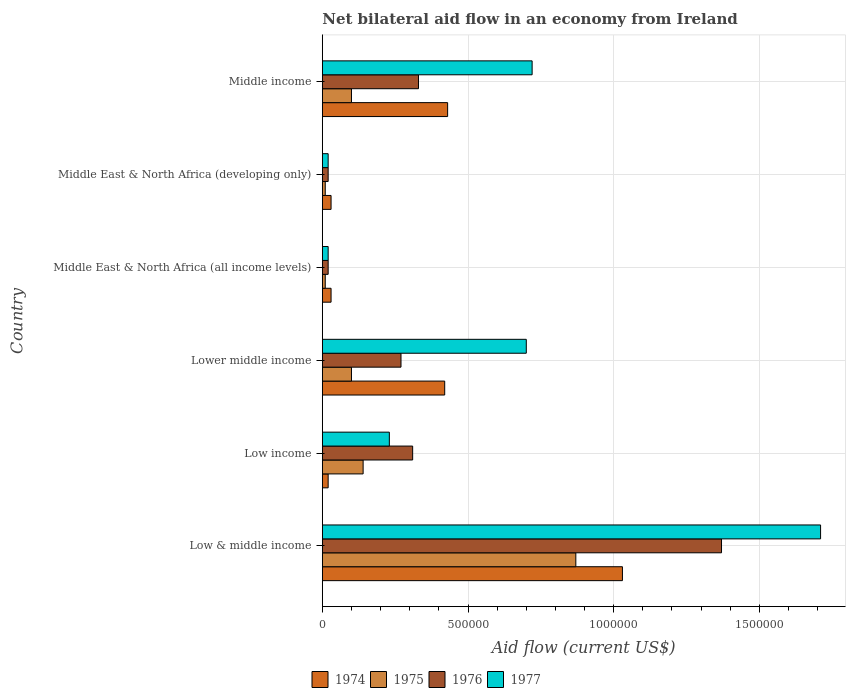How many different coloured bars are there?
Provide a short and direct response. 4. How many groups of bars are there?
Keep it short and to the point. 6. Are the number of bars on each tick of the Y-axis equal?
Provide a short and direct response. Yes. How many bars are there on the 5th tick from the bottom?
Ensure brevity in your answer.  4. What is the label of the 2nd group of bars from the top?
Offer a very short reply. Middle East & North Africa (developing only). In how many cases, is the number of bars for a given country not equal to the number of legend labels?
Provide a short and direct response. 0. Across all countries, what is the maximum net bilateral aid flow in 1974?
Give a very brief answer. 1.03e+06. Across all countries, what is the minimum net bilateral aid flow in 1976?
Give a very brief answer. 2.00e+04. In which country was the net bilateral aid flow in 1975 maximum?
Offer a very short reply. Low & middle income. What is the total net bilateral aid flow in 1977 in the graph?
Your answer should be very brief. 3.40e+06. What is the difference between the net bilateral aid flow in 1974 in Low & middle income and that in Middle income?
Give a very brief answer. 6.00e+05. What is the difference between the net bilateral aid flow in 1977 in Middle East & North Africa (all income levels) and the net bilateral aid flow in 1975 in Low & middle income?
Provide a short and direct response. -8.50e+05. What is the average net bilateral aid flow in 1975 per country?
Give a very brief answer. 2.05e+05. What is the difference between the net bilateral aid flow in 1975 and net bilateral aid flow in 1977 in Middle East & North Africa (developing only)?
Offer a very short reply. -10000. What is the ratio of the net bilateral aid flow in 1977 in Low income to that in Middle East & North Africa (developing only)?
Provide a short and direct response. 11.5. What is the difference between the highest and the second highest net bilateral aid flow in 1976?
Give a very brief answer. 1.04e+06. What is the difference between the highest and the lowest net bilateral aid flow in 1974?
Provide a succinct answer. 1.01e+06. What does the 3rd bar from the top in Lower middle income represents?
Offer a very short reply. 1975. Is it the case that in every country, the sum of the net bilateral aid flow in 1977 and net bilateral aid flow in 1974 is greater than the net bilateral aid flow in 1975?
Provide a short and direct response. Yes. How many bars are there?
Give a very brief answer. 24. How many countries are there in the graph?
Give a very brief answer. 6. Are the values on the major ticks of X-axis written in scientific E-notation?
Give a very brief answer. No. Does the graph contain any zero values?
Your response must be concise. No. Does the graph contain grids?
Your answer should be very brief. Yes. How many legend labels are there?
Give a very brief answer. 4. How are the legend labels stacked?
Your answer should be compact. Horizontal. What is the title of the graph?
Provide a succinct answer. Net bilateral aid flow in an economy from Ireland. What is the Aid flow (current US$) in 1974 in Low & middle income?
Your response must be concise. 1.03e+06. What is the Aid flow (current US$) of 1975 in Low & middle income?
Make the answer very short. 8.70e+05. What is the Aid flow (current US$) of 1976 in Low & middle income?
Offer a terse response. 1.37e+06. What is the Aid flow (current US$) of 1977 in Low & middle income?
Keep it short and to the point. 1.71e+06. What is the Aid flow (current US$) of 1975 in Low income?
Your answer should be compact. 1.40e+05. What is the Aid flow (current US$) of 1976 in Low income?
Offer a terse response. 3.10e+05. What is the Aid flow (current US$) in 1975 in Lower middle income?
Your answer should be very brief. 1.00e+05. What is the Aid flow (current US$) of 1976 in Lower middle income?
Offer a very short reply. 2.70e+05. What is the Aid flow (current US$) in 1977 in Lower middle income?
Make the answer very short. 7.00e+05. What is the Aid flow (current US$) of 1975 in Middle East & North Africa (all income levels)?
Make the answer very short. 10000. What is the Aid flow (current US$) of 1977 in Middle East & North Africa (all income levels)?
Keep it short and to the point. 2.00e+04. What is the Aid flow (current US$) of 1975 in Middle East & North Africa (developing only)?
Provide a short and direct response. 10000. What is the Aid flow (current US$) in 1976 in Middle East & North Africa (developing only)?
Make the answer very short. 2.00e+04. What is the Aid flow (current US$) of 1977 in Middle East & North Africa (developing only)?
Offer a very short reply. 2.00e+04. What is the Aid flow (current US$) in 1975 in Middle income?
Provide a succinct answer. 1.00e+05. What is the Aid flow (current US$) in 1977 in Middle income?
Offer a terse response. 7.20e+05. Across all countries, what is the maximum Aid flow (current US$) of 1974?
Your response must be concise. 1.03e+06. Across all countries, what is the maximum Aid flow (current US$) in 1975?
Provide a succinct answer. 8.70e+05. Across all countries, what is the maximum Aid flow (current US$) in 1976?
Your answer should be compact. 1.37e+06. Across all countries, what is the maximum Aid flow (current US$) in 1977?
Give a very brief answer. 1.71e+06. Across all countries, what is the minimum Aid flow (current US$) in 1974?
Make the answer very short. 2.00e+04. What is the total Aid flow (current US$) of 1974 in the graph?
Give a very brief answer. 1.96e+06. What is the total Aid flow (current US$) in 1975 in the graph?
Provide a short and direct response. 1.23e+06. What is the total Aid flow (current US$) of 1976 in the graph?
Make the answer very short. 2.32e+06. What is the total Aid flow (current US$) of 1977 in the graph?
Your answer should be very brief. 3.40e+06. What is the difference between the Aid flow (current US$) in 1974 in Low & middle income and that in Low income?
Make the answer very short. 1.01e+06. What is the difference between the Aid flow (current US$) of 1975 in Low & middle income and that in Low income?
Your response must be concise. 7.30e+05. What is the difference between the Aid flow (current US$) in 1976 in Low & middle income and that in Low income?
Your answer should be compact. 1.06e+06. What is the difference between the Aid flow (current US$) in 1977 in Low & middle income and that in Low income?
Provide a succinct answer. 1.48e+06. What is the difference between the Aid flow (current US$) in 1974 in Low & middle income and that in Lower middle income?
Make the answer very short. 6.10e+05. What is the difference between the Aid flow (current US$) in 1975 in Low & middle income and that in Lower middle income?
Your answer should be compact. 7.70e+05. What is the difference between the Aid flow (current US$) of 1976 in Low & middle income and that in Lower middle income?
Offer a terse response. 1.10e+06. What is the difference between the Aid flow (current US$) of 1977 in Low & middle income and that in Lower middle income?
Ensure brevity in your answer.  1.01e+06. What is the difference between the Aid flow (current US$) in 1974 in Low & middle income and that in Middle East & North Africa (all income levels)?
Ensure brevity in your answer.  1.00e+06. What is the difference between the Aid flow (current US$) of 1975 in Low & middle income and that in Middle East & North Africa (all income levels)?
Ensure brevity in your answer.  8.60e+05. What is the difference between the Aid flow (current US$) of 1976 in Low & middle income and that in Middle East & North Africa (all income levels)?
Your answer should be very brief. 1.35e+06. What is the difference between the Aid flow (current US$) in 1977 in Low & middle income and that in Middle East & North Africa (all income levels)?
Make the answer very short. 1.69e+06. What is the difference between the Aid flow (current US$) of 1975 in Low & middle income and that in Middle East & North Africa (developing only)?
Your answer should be very brief. 8.60e+05. What is the difference between the Aid flow (current US$) in 1976 in Low & middle income and that in Middle East & North Africa (developing only)?
Offer a very short reply. 1.35e+06. What is the difference between the Aid flow (current US$) of 1977 in Low & middle income and that in Middle East & North Africa (developing only)?
Offer a very short reply. 1.69e+06. What is the difference between the Aid flow (current US$) in 1975 in Low & middle income and that in Middle income?
Give a very brief answer. 7.70e+05. What is the difference between the Aid flow (current US$) of 1976 in Low & middle income and that in Middle income?
Make the answer very short. 1.04e+06. What is the difference between the Aid flow (current US$) in 1977 in Low & middle income and that in Middle income?
Ensure brevity in your answer.  9.90e+05. What is the difference between the Aid flow (current US$) in 1974 in Low income and that in Lower middle income?
Give a very brief answer. -4.00e+05. What is the difference between the Aid flow (current US$) of 1975 in Low income and that in Lower middle income?
Give a very brief answer. 4.00e+04. What is the difference between the Aid flow (current US$) in 1976 in Low income and that in Lower middle income?
Give a very brief answer. 4.00e+04. What is the difference between the Aid flow (current US$) in 1977 in Low income and that in Lower middle income?
Your answer should be compact. -4.70e+05. What is the difference between the Aid flow (current US$) in 1974 in Low income and that in Middle East & North Africa (all income levels)?
Keep it short and to the point. -10000. What is the difference between the Aid flow (current US$) in 1974 in Low income and that in Middle East & North Africa (developing only)?
Provide a short and direct response. -10000. What is the difference between the Aid flow (current US$) in 1975 in Low income and that in Middle East & North Africa (developing only)?
Provide a short and direct response. 1.30e+05. What is the difference between the Aid flow (current US$) of 1974 in Low income and that in Middle income?
Your answer should be very brief. -4.10e+05. What is the difference between the Aid flow (current US$) of 1975 in Low income and that in Middle income?
Ensure brevity in your answer.  4.00e+04. What is the difference between the Aid flow (current US$) in 1977 in Low income and that in Middle income?
Your answer should be very brief. -4.90e+05. What is the difference between the Aid flow (current US$) in 1977 in Lower middle income and that in Middle East & North Africa (all income levels)?
Provide a short and direct response. 6.80e+05. What is the difference between the Aid flow (current US$) in 1976 in Lower middle income and that in Middle East & North Africa (developing only)?
Keep it short and to the point. 2.50e+05. What is the difference between the Aid flow (current US$) of 1977 in Lower middle income and that in Middle East & North Africa (developing only)?
Offer a terse response. 6.80e+05. What is the difference between the Aid flow (current US$) in 1974 in Lower middle income and that in Middle income?
Make the answer very short. -10000. What is the difference between the Aid flow (current US$) in 1975 in Lower middle income and that in Middle income?
Offer a very short reply. 0. What is the difference between the Aid flow (current US$) of 1974 in Middle East & North Africa (all income levels) and that in Middle East & North Africa (developing only)?
Your response must be concise. 0. What is the difference between the Aid flow (current US$) of 1977 in Middle East & North Africa (all income levels) and that in Middle East & North Africa (developing only)?
Offer a terse response. 0. What is the difference between the Aid flow (current US$) of 1974 in Middle East & North Africa (all income levels) and that in Middle income?
Give a very brief answer. -4.00e+05. What is the difference between the Aid flow (current US$) of 1976 in Middle East & North Africa (all income levels) and that in Middle income?
Keep it short and to the point. -3.10e+05. What is the difference between the Aid flow (current US$) of 1977 in Middle East & North Africa (all income levels) and that in Middle income?
Provide a short and direct response. -7.00e+05. What is the difference between the Aid flow (current US$) in 1974 in Middle East & North Africa (developing only) and that in Middle income?
Keep it short and to the point. -4.00e+05. What is the difference between the Aid flow (current US$) in 1975 in Middle East & North Africa (developing only) and that in Middle income?
Make the answer very short. -9.00e+04. What is the difference between the Aid flow (current US$) of 1976 in Middle East & North Africa (developing only) and that in Middle income?
Keep it short and to the point. -3.10e+05. What is the difference between the Aid flow (current US$) of 1977 in Middle East & North Africa (developing only) and that in Middle income?
Your response must be concise. -7.00e+05. What is the difference between the Aid flow (current US$) in 1974 in Low & middle income and the Aid flow (current US$) in 1975 in Low income?
Your response must be concise. 8.90e+05. What is the difference between the Aid flow (current US$) in 1974 in Low & middle income and the Aid flow (current US$) in 1976 in Low income?
Provide a succinct answer. 7.20e+05. What is the difference between the Aid flow (current US$) in 1974 in Low & middle income and the Aid flow (current US$) in 1977 in Low income?
Provide a short and direct response. 8.00e+05. What is the difference between the Aid flow (current US$) in 1975 in Low & middle income and the Aid flow (current US$) in 1976 in Low income?
Ensure brevity in your answer.  5.60e+05. What is the difference between the Aid flow (current US$) of 1975 in Low & middle income and the Aid flow (current US$) of 1977 in Low income?
Provide a short and direct response. 6.40e+05. What is the difference between the Aid flow (current US$) of 1976 in Low & middle income and the Aid flow (current US$) of 1977 in Low income?
Ensure brevity in your answer.  1.14e+06. What is the difference between the Aid flow (current US$) in 1974 in Low & middle income and the Aid flow (current US$) in 1975 in Lower middle income?
Keep it short and to the point. 9.30e+05. What is the difference between the Aid flow (current US$) of 1974 in Low & middle income and the Aid flow (current US$) of 1976 in Lower middle income?
Provide a succinct answer. 7.60e+05. What is the difference between the Aid flow (current US$) in 1974 in Low & middle income and the Aid flow (current US$) in 1977 in Lower middle income?
Keep it short and to the point. 3.30e+05. What is the difference between the Aid flow (current US$) of 1975 in Low & middle income and the Aid flow (current US$) of 1976 in Lower middle income?
Ensure brevity in your answer.  6.00e+05. What is the difference between the Aid flow (current US$) of 1975 in Low & middle income and the Aid flow (current US$) of 1977 in Lower middle income?
Ensure brevity in your answer.  1.70e+05. What is the difference between the Aid flow (current US$) of 1976 in Low & middle income and the Aid flow (current US$) of 1977 in Lower middle income?
Your response must be concise. 6.70e+05. What is the difference between the Aid flow (current US$) of 1974 in Low & middle income and the Aid flow (current US$) of 1975 in Middle East & North Africa (all income levels)?
Offer a very short reply. 1.02e+06. What is the difference between the Aid flow (current US$) of 1974 in Low & middle income and the Aid flow (current US$) of 1976 in Middle East & North Africa (all income levels)?
Offer a terse response. 1.01e+06. What is the difference between the Aid flow (current US$) in 1974 in Low & middle income and the Aid flow (current US$) in 1977 in Middle East & North Africa (all income levels)?
Your answer should be compact. 1.01e+06. What is the difference between the Aid flow (current US$) of 1975 in Low & middle income and the Aid flow (current US$) of 1976 in Middle East & North Africa (all income levels)?
Make the answer very short. 8.50e+05. What is the difference between the Aid flow (current US$) in 1975 in Low & middle income and the Aid flow (current US$) in 1977 in Middle East & North Africa (all income levels)?
Keep it short and to the point. 8.50e+05. What is the difference between the Aid flow (current US$) of 1976 in Low & middle income and the Aid flow (current US$) of 1977 in Middle East & North Africa (all income levels)?
Your answer should be compact. 1.35e+06. What is the difference between the Aid flow (current US$) of 1974 in Low & middle income and the Aid flow (current US$) of 1975 in Middle East & North Africa (developing only)?
Provide a succinct answer. 1.02e+06. What is the difference between the Aid flow (current US$) of 1974 in Low & middle income and the Aid flow (current US$) of 1976 in Middle East & North Africa (developing only)?
Ensure brevity in your answer.  1.01e+06. What is the difference between the Aid flow (current US$) in 1974 in Low & middle income and the Aid flow (current US$) in 1977 in Middle East & North Africa (developing only)?
Ensure brevity in your answer.  1.01e+06. What is the difference between the Aid flow (current US$) in 1975 in Low & middle income and the Aid flow (current US$) in 1976 in Middle East & North Africa (developing only)?
Your answer should be compact. 8.50e+05. What is the difference between the Aid flow (current US$) in 1975 in Low & middle income and the Aid flow (current US$) in 1977 in Middle East & North Africa (developing only)?
Offer a terse response. 8.50e+05. What is the difference between the Aid flow (current US$) in 1976 in Low & middle income and the Aid flow (current US$) in 1977 in Middle East & North Africa (developing only)?
Provide a succinct answer. 1.35e+06. What is the difference between the Aid flow (current US$) of 1974 in Low & middle income and the Aid flow (current US$) of 1975 in Middle income?
Your answer should be very brief. 9.30e+05. What is the difference between the Aid flow (current US$) in 1974 in Low & middle income and the Aid flow (current US$) in 1977 in Middle income?
Your answer should be compact. 3.10e+05. What is the difference between the Aid flow (current US$) of 1975 in Low & middle income and the Aid flow (current US$) of 1976 in Middle income?
Your answer should be compact. 5.40e+05. What is the difference between the Aid flow (current US$) in 1976 in Low & middle income and the Aid flow (current US$) in 1977 in Middle income?
Offer a very short reply. 6.50e+05. What is the difference between the Aid flow (current US$) in 1974 in Low income and the Aid flow (current US$) in 1975 in Lower middle income?
Offer a terse response. -8.00e+04. What is the difference between the Aid flow (current US$) of 1974 in Low income and the Aid flow (current US$) of 1977 in Lower middle income?
Give a very brief answer. -6.80e+05. What is the difference between the Aid flow (current US$) of 1975 in Low income and the Aid flow (current US$) of 1976 in Lower middle income?
Offer a terse response. -1.30e+05. What is the difference between the Aid flow (current US$) of 1975 in Low income and the Aid flow (current US$) of 1977 in Lower middle income?
Your answer should be very brief. -5.60e+05. What is the difference between the Aid flow (current US$) of 1976 in Low income and the Aid flow (current US$) of 1977 in Lower middle income?
Keep it short and to the point. -3.90e+05. What is the difference between the Aid flow (current US$) in 1974 in Low income and the Aid flow (current US$) in 1976 in Middle East & North Africa (all income levels)?
Your response must be concise. 0. What is the difference between the Aid flow (current US$) in 1975 in Low income and the Aid flow (current US$) in 1977 in Middle East & North Africa (all income levels)?
Your answer should be very brief. 1.20e+05. What is the difference between the Aid flow (current US$) of 1974 in Low income and the Aid flow (current US$) of 1977 in Middle East & North Africa (developing only)?
Give a very brief answer. 0. What is the difference between the Aid flow (current US$) in 1975 in Low income and the Aid flow (current US$) in 1976 in Middle East & North Africa (developing only)?
Your answer should be very brief. 1.20e+05. What is the difference between the Aid flow (current US$) of 1974 in Low income and the Aid flow (current US$) of 1975 in Middle income?
Your answer should be very brief. -8.00e+04. What is the difference between the Aid flow (current US$) in 1974 in Low income and the Aid flow (current US$) in 1976 in Middle income?
Offer a terse response. -3.10e+05. What is the difference between the Aid flow (current US$) of 1974 in Low income and the Aid flow (current US$) of 1977 in Middle income?
Your response must be concise. -7.00e+05. What is the difference between the Aid flow (current US$) of 1975 in Low income and the Aid flow (current US$) of 1977 in Middle income?
Provide a succinct answer. -5.80e+05. What is the difference between the Aid flow (current US$) in 1976 in Low income and the Aid flow (current US$) in 1977 in Middle income?
Ensure brevity in your answer.  -4.10e+05. What is the difference between the Aid flow (current US$) in 1974 in Lower middle income and the Aid flow (current US$) in 1975 in Middle East & North Africa (all income levels)?
Give a very brief answer. 4.10e+05. What is the difference between the Aid flow (current US$) of 1974 in Lower middle income and the Aid flow (current US$) of 1976 in Middle East & North Africa (all income levels)?
Ensure brevity in your answer.  4.00e+05. What is the difference between the Aid flow (current US$) in 1975 in Lower middle income and the Aid flow (current US$) in 1976 in Middle East & North Africa (all income levels)?
Offer a very short reply. 8.00e+04. What is the difference between the Aid flow (current US$) of 1976 in Lower middle income and the Aid flow (current US$) of 1977 in Middle East & North Africa (all income levels)?
Your answer should be compact. 2.50e+05. What is the difference between the Aid flow (current US$) of 1974 in Lower middle income and the Aid flow (current US$) of 1976 in Middle East & North Africa (developing only)?
Make the answer very short. 4.00e+05. What is the difference between the Aid flow (current US$) in 1974 in Lower middle income and the Aid flow (current US$) in 1977 in Middle East & North Africa (developing only)?
Give a very brief answer. 4.00e+05. What is the difference between the Aid flow (current US$) of 1974 in Lower middle income and the Aid flow (current US$) of 1975 in Middle income?
Make the answer very short. 3.20e+05. What is the difference between the Aid flow (current US$) in 1974 in Lower middle income and the Aid flow (current US$) in 1976 in Middle income?
Your response must be concise. 9.00e+04. What is the difference between the Aid flow (current US$) in 1975 in Lower middle income and the Aid flow (current US$) in 1976 in Middle income?
Give a very brief answer. -2.30e+05. What is the difference between the Aid flow (current US$) in 1975 in Lower middle income and the Aid flow (current US$) in 1977 in Middle income?
Make the answer very short. -6.20e+05. What is the difference between the Aid flow (current US$) in 1976 in Lower middle income and the Aid flow (current US$) in 1977 in Middle income?
Offer a terse response. -4.50e+05. What is the difference between the Aid flow (current US$) in 1974 in Middle East & North Africa (all income levels) and the Aid flow (current US$) in 1975 in Middle East & North Africa (developing only)?
Offer a very short reply. 2.00e+04. What is the difference between the Aid flow (current US$) of 1974 in Middle East & North Africa (all income levels) and the Aid flow (current US$) of 1977 in Middle East & North Africa (developing only)?
Provide a succinct answer. 10000. What is the difference between the Aid flow (current US$) in 1974 in Middle East & North Africa (all income levels) and the Aid flow (current US$) in 1975 in Middle income?
Ensure brevity in your answer.  -7.00e+04. What is the difference between the Aid flow (current US$) of 1974 in Middle East & North Africa (all income levels) and the Aid flow (current US$) of 1976 in Middle income?
Give a very brief answer. -3.00e+05. What is the difference between the Aid flow (current US$) in 1974 in Middle East & North Africa (all income levels) and the Aid flow (current US$) in 1977 in Middle income?
Ensure brevity in your answer.  -6.90e+05. What is the difference between the Aid flow (current US$) of 1975 in Middle East & North Africa (all income levels) and the Aid flow (current US$) of 1976 in Middle income?
Give a very brief answer. -3.20e+05. What is the difference between the Aid flow (current US$) of 1975 in Middle East & North Africa (all income levels) and the Aid flow (current US$) of 1977 in Middle income?
Keep it short and to the point. -7.10e+05. What is the difference between the Aid flow (current US$) in 1976 in Middle East & North Africa (all income levels) and the Aid flow (current US$) in 1977 in Middle income?
Offer a terse response. -7.00e+05. What is the difference between the Aid flow (current US$) in 1974 in Middle East & North Africa (developing only) and the Aid flow (current US$) in 1975 in Middle income?
Your response must be concise. -7.00e+04. What is the difference between the Aid flow (current US$) in 1974 in Middle East & North Africa (developing only) and the Aid flow (current US$) in 1977 in Middle income?
Ensure brevity in your answer.  -6.90e+05. What is the difference between the Aid flow (current US$) in 1975 in Middle East & North Africa (developing only) and the Aid flow (current US$) in 1976 in Middle income?
Provide a short and direct response. -3.20e+05. What is the difference between the Aid flow (current US$) of 1975 in Middle East & North Africa (developing only) and the Aid flow (current US$) of 1977 in Middle income?
Your answer should be very brief. -7.10e+05. What is the difference between the Aid flow (current US$) in 1976 in Middle East & North Africa (developing only) and the Aid flow (current US$) in 1977 in Middle income?
Make the answer very short. -7.00e+05. What is the average Aid flow (current US$) of 1974 per country?
Provide a short and direct response. 3.27e+05. What is the average Aid flow (current US$) of 1975 per country?
Give a very brief answer. 2.05e+05. What is the average Aid flow (current US$) of 1976 per country?
Your answer should be very brief. 3.87e+05. What is the average Aid flow (current US$) in 1977 per country?
Your answer should be very brief. 5.67e+05. What is the difference between the Aid flow (current US$) in 1974 and Aid flow (current US$) in 1975 in Low & middle income?
Your answer should be compact. 1.60e+05. What is the difference between the Aid flow (current US$) of 1974 and Aid flow (current US$) of 1977 in Low & middle income?
Your answer should be compact. -6.80e+05. What is the difference between the Aid flow (current US$) in 1975 and Aid flow (current US$) in 1976 in Low & middle income?
Keep it short and to the point. -5.00e+05. What is the difference between the Aid flow (current US$) of 1975 and Aid flow (current US$) of 1977 in Low & middle income?
Give a very brief answer. -8.40e+05. What is the difference between the Aid flow (current US$) of 1976 and Aid flow (current US$) of 1977 in Low & middle income?
Keep it short and to the point. -3.40e+05. What is the difference between the Aid flow (current US$) of 1974 and Aid flow (current US$) of 1975 in Low income?
Your response must be concise. -1.20e+05. What is the difference between the Aid flow (current US$) of 1974 and Aid flow (current US$) of 1976 in Low income?
Your response must be concise. -2.90e+05. What is the difference between the Aid flow (current US$) in 1975 and Aid flow (current US$) in 1977 in Low income?
Your answer should be compact. -9.00e+04. What is the difference between the Aid flow (current US$) of 1974 and Aid flow (current US$) of 1976 in Lower middle income?
Give a very brief answer. 1.50e+05. What is the difference between the Aid flow (current US$) in 1974 and Aid flow (current US$) in 1977 in Lower middle income?
Offer a terse response. -2.80e+05. What is the difference between the Aid flow (current US$) of 1975 and Aid flow (current US$) of 1977 in Lower middle income?
Give a very brief answer. -6.00e+05. What is the difference between the Aid flow (current US$) of 1976 and Aid flow (current US$) of 1977 in Lower middle income?
Keep it short and to the point. -4.30e+05. What is the difference between the Aid flow (current US$) of 1974 and Aid flow (current US$) of 1977 in Middle East & North Africa (all income levels)?
Offer a very short reply. 10000. What is the difference between the Aid flow (current US$) of 1975 and Aid flow (current US$) of 1977 in Middle East & North Africa (all income levels)?
Offer a very short reply. -10000. What is the difference between the Aid flow (current US$) in 1974 and Aid flow (current US$) in 1976 in Middle East & North Africa (developing only)?
Offer a terse response. 10000. What is the difference between the Aid flow (current US$) of 1974 and Aid flow (current US$) of 1977 in Middle East & North Africa (developing only)?
Offer a terse response. 10000. What is the difference between the Aid flow (current US$) in 1975 and Aid flow (current US$) in 1976 in Middle East & North Africa (developing only)?
Offer a terse response. -10000. What is the difference between the Aid flow (current US$) of 1975 and Aid flow (current US$) of 1977 in Middle East & North Africa (developing only)?
Offer a very short reply. -10000. What is the difference between the Aid flow (current US$) of 1974 and Aid flow (current US$) of 1977 in Middle income?
Your answer should be very brief. -2.90e+05. What is the difference between the Aid flow (current US$) in 1975 and Aid flow (current US$) in 1976 in Middle income?
Your response must be concise. -2.30e+05. What is the difference between the Aid flow (current US$) in 1975 and Aid flow (current US$) in 1977 in Middle income?
Offer a very short reply. -6.20e+05. What is the difference between the Aid flow (current US$) of 1976 and Aid flow (current US$) of 1977 in Middle income?
Keep it short and to the point. -3.90e+05. What is the ratio of the Aid flow (current US$) in 1974 in Low & middle income to that in Low income?
Offer a very short reply. 51.5. What is the ratio of the Aid flow (current US$) of 1975 in Low & middle income to that in Low income?
Ensure brevity in your answer.  6.21. What is the ratio of the Aid flow (current US$) of 1976 in Low & middle income to that in Low income?
Your answer should be very brief. 4.42. What is the ratio of the Aid flow (current US$) of 1977 in Low & middle income to that in Low income?
Give a very brief answer. 7.43. What is the ratio of the Aid flow (current US$) of 1974 in Low & middle income to that in Lower middle income?
Your answer should be compact. 2.45. What is the ratio of the Aid flow (current US$) in 1975 in Low & middle income to that in Lower middle income?
Make the answer very short. 8.7. What is the ratio of the Aid flow (current US$) of 1976 in Low & middle income to that in Lower middle income?
Make the answer very short. 5.07. What is the ratio of the Aid flow (current US$) of 1977 in Low & middle income to that in Lower middle income?
Ensure brevity in your answer.  2.44. What is the ratio of the Aid flow (current US$) in 1974 in Low & middle income to that in Middle East & North Africa (all income levels)?
Give a very brief answer. 34.33. What is the ratio of the Aid flow (current US$) of 1975 in Low & middle income to that in Middle East & North Africa (all income levels)?
Your answer should be very brief. 87. What is the ratio of the Aid flow (current US$) in 1976 in Low & middle income to that in Middle East & North Africa (all income levels)?
Your answer should be very brief. 68.5. What is the ratio of the Aid flow (current US$) in 1977 in Low & middle income to that in Middle East & North Africa (all income levels)?
Your answer should be compact. 85.5. What is the ratio of the Aid flow (current US$) of 1974 in Low & middle income to that in Middle East & North Africa (developing only)?
Your answer should be very brief. 34.33. What is the ratio of the Aid flow (current US$) in 1976 in Low & middle income to that in Middle East & North Africa (developing only)?
Offer a terse response. 68.5. What is the ratio of the Aid flow (current US$) of 1977 in Low & middle income to that in Middle East & North Africa (developing only)?
Ensure brevity in your answer.  85.5. What is the ratio of the Aid flow (current US$) of 1974 in Low & middle income to that in Middle income?
Provide a succinct answer. 2.4. What is the ratio of the Aid flow (current US$) of 1975 in Low & middle income to that in Middle income?
Your answer should be very brief. 8.7. What is the ratio of the Aid flow (current US$) of 1976 in Low & middle income to that in Middle income?
Your answer should be compact. 4.15. What is the ratio of the Aid flow (current US$) in 1977 in Low & middle income to that in Middle income?
Provide a succinct answer. 2.38. What is the ratio of the Aid flow (current US$) in 1974 in Low income to that in Lower middle income?
Provide a succinct answer. 0.05. What is the ratio of the Aid flow (current US$) of 1976 in Low income to that in Lower middle income?
Ensure brevity in your answer.  1.15. What is the ratio of the Aid flow (current US$) in 1977 in Low income to that in Lower middle income?
Your answer should be very brief. 0.33. What is the ratio of the Aid flow (current US$) of 1974 in Low income to that in Middle East & North Africa (developing only)?
Your answer should be compact. 0.67. What is the ratio of the Aid flow (current US$) in 1975 in Low income to that in Middle East & North Africa (developing only)?
Ensure brevity in your answer.  14. What is the ratio of the Aid flow (current US$) of 1974 in Low income to that in Middle income?
Ensure brevity in your answer.  0.05. What is the ratio of the Aid flow (current US$) of 1976 in Low income to that in Middle income?
Offer a terse response. 0.94. What is the ratio of the Aid flow (current US$) of 1977 in Low income to that in Middle income?
Make the answer very short. 0.32. What is the ratio of the Aid flow (current US$) of 1974 in Lower middle income to that in Middle East & North Africa (all income levels)?
Give a very brief answer. 14. What is the ratio of the Aid flow (current US$) of 1975 in Lower middle income to that in Middle East & North Africa (all income levels)?
Ensure brevity in your answer.  10. What is the ratio of the Aid flow (current US$) of 1976 in Lower middle income to that in Middle East & North Africa (developing only)?
Give a very brief answer. 13.5. What is the ratio of the Aid flow (current US$) in 1977 in Lower middle income to that in Middle East & North Africa (developing only)?
Offer a terse response. 35. What is the ratio of the Aid flow (current US$) in 1974 in Lower middle income to that in Middle income?
Offer a very short reply. 0.98. What is the ratio of the Aid flow (current US$) in 1976 in Lower middle income to that in Middle income?
Offer a terse response. 0.82. What is the ratio of the Aid flow (current US$) of 1977 in Lower middle income to that in Middle income?
Make the answer very short. 0.97. What is the ratio of the Aid flow (current US$) in 1974 in Middle East & North Africa (all income levels) to that in Middle East & North Africa (developing only)?
Offer a very short reply. 1. What is the ratio of the Aid flow (current US$) of 1975 in Middle East & North Africa (all income levels) to that in Middle East & North Africa (developing only)?
Give a very brief answer. 1. What is the ratio of the Aid flow (current US$) in 1976 in Middle East & North Africa (all income levels) to that in Middle East & North Africa (developing only)?
Provide a succinct answer. 1. What is the ratio of the Aid flow (current US$) in 1977 in Middle East & North Africa (all income levels) to that in Middle East & North Africa (developing only)?
Keep it short and to the point. 1. What is the ratio of the Aid flow (current US$) in 1974 in Middle East & North Africa (all income levels) to that in Middle income?
Provide a short and direct response. 0.07. What is the ratio of the Aid flow (current US$) in 1975 in Middle East & North Africa (all income levels) to that in Middle income?
Your answer should be compact. 0.1. What is the ratio of the Aid flow (current US$) of 1976 in Middle East & North Africa (all income levels) to that in Middle income?
Give a very brief answer. 0.06. What is the ratio of the Aid flow (current US$) of 1977 in Middle East & North Africa (all income levels) to that in Middle income?
Your answer should be compact. 0.03. What is the ratio of the Aid flow (current US$) in 1974 in Middle East & North Africa (developing only) to that in Middle income?
Your answer should be compact. 0.07. What is the ratio of the Aid flow (current US$) of 1976 in Middle East & North Africa (developing only) to that in Middle income?
Provide a short and direct response. 0.06. What is the ratio of the Aid flow (current US$) of 1977 in Middle East & North Africa (developing only) to that in Middle income?
Offer a terse response. 0.03. What is the difference between the highest and the second highest Aid flow (current US$) in 1975?
Provide a short and direct response. 7.30e+05. What is the difference between the highest and the second highest Aid flow (current US$) in 1976?
Offer a very short reply. 1.04e+06. What is the difference between the highest and the second highest Aid flow (current US$) of 1977?
Your answer should be compact. 9.90e+05. What is the difference between the highest and the lowest Aid flow (current US$) in 1974?
Provide a succinct answer. 1.01e+06. What is the difference between the highest and the lowest Aid flow (current US$) in 1975?
Offer a very short reply. 8.60e+05. What is the difference between the highest and the lowest Aid flow (current US$) in 1976?
Keep it short and to the point. 1.35e+06. What is the difference between the highest and the lowest Aid flow (current US$) of 1977?
Make the answer very short. 1.69e+06. 